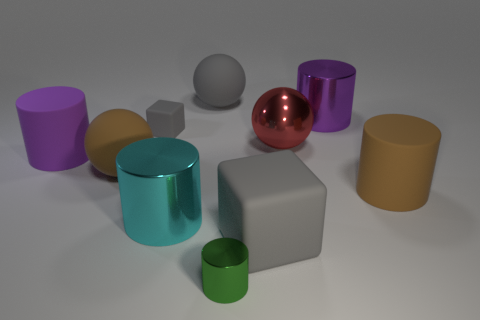How many matte things are either blue blocks or green cylinders?
Your answer should be compact. 0. What shape is the tiny thing that is the same color as the large rubber block?
Make the answer very short. Cube. What number of purple metallic cylinders are there?
Keep it short and to the point. 1. Are the gray object to the right of the green shiny cylinder and the big brown object that is to the left of the large gray sphere made of the same material?
Give a very brief answer. Yes. What size is the purple cylinder that is the same material as the red ball?
Give a very brief answer. Large. The large brown object to the left of the small shiny thing has what shape?
Keep it short and to the point. Sphere. There is a big cylinder behind the large purple matte object; does it have the same color as the big matte cylinder that is on the left side of the green object?
Make the answer very short. Yes. What size is the other block that is the same color as the big matte cube?
Give a very brief answer. Small. Are there any cyan metal cylinders?
Provide a short and direct response. Yes. The large brown object that is left of the large gray rubber object that is in front of the matte ball in front of the large purple rubber cylinder is what shape?
Make the answer very short. Sphere. 